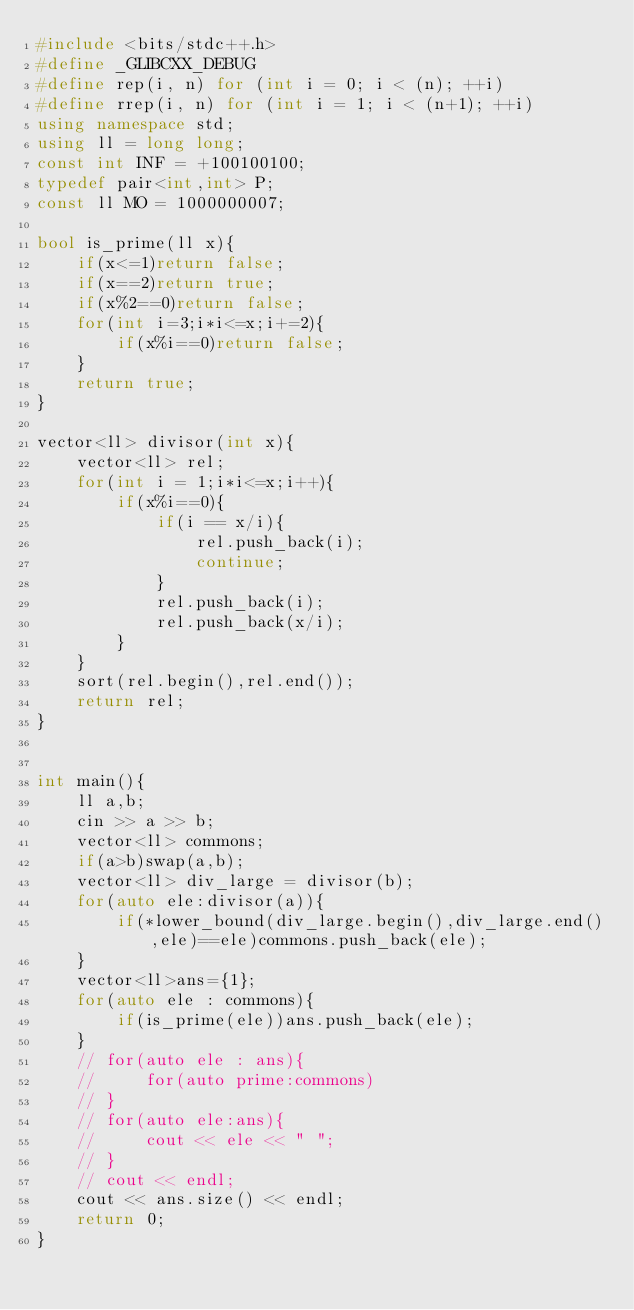Convert code to text. <code><loc_0><loc_0><loc_500><loc_500><_C++_>#include <bits/stdc++.h>
#define _GLIBCXX_DEBUG
#define rep(i, n) for (int i = 0; i < (n); ++i)
#define rrep(i, n) for (int i = 1; i < (n+1); ++i)
using namespace std;
using ll = long long;
const int INF = +100100100;
typedef pair<int,int> P;
const ll MO = 1000000007;

bool is_prime(ll x){
    if(x<=1)return false;
    if(x==2)return true;
    if(x%2==0)return false;
    for(int i=3;i*i<=x;i+=2){
        if(x%i==0)return false;
    }
    return true;
}

vector<ll> divisor(int x){
    vector<ll> rel;
    for(int i = 1;i*i<=x;i++){
        if(x%i==0){
            if(i == x/i){
                rel.push_back(i);
                continue;
            }
            rel.push_back(i);
            rel.push_back(x/i);
        }
    }
    sort(rel.begin(),rel.end());
    return rel;
}


int main(){
    ll a,b;
    cin >> a >> b;
    vector<ll> commons;
    if(a>b)swap(a,b);
    vector<ll> div_large = divisor(b);
    for(auto ele:divisor(a)){
        if(*lower_bound(div_large.begin(),div_large.end(),ele)==ele)commons.push_back(ele);
    }
    vector<ll>ans={1};
    for(auto ele : commons){
        if(is_prime(ele))ans.push_back(ele);
    }
    // for(auto ele : ans){
    //     for(auto prime:commons)
    // }
    // for(auto ele:ans){
    //     cout << ele << " ";
    // }
    // cout << endl;
    cout << ans.size() << endl;
    return 0;
}</code> 